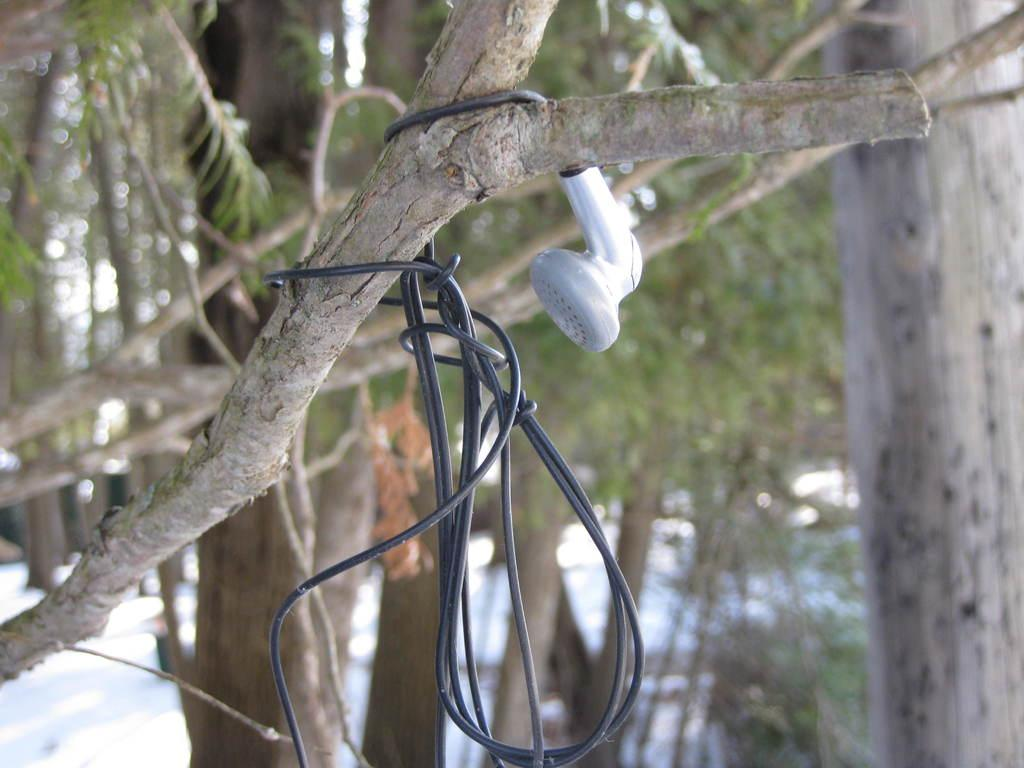What color is the wire that is visible in the image? The wire in the image is black. What is the wire connected to? The wire appears to be connected to a telephone. What can be seen in the background of the image? There are trees in the background of the image. Is there a parcel being delivered by a kite in the image? No, there is no parcel or kite present in the image. Is there a shop visible in the image? No, there is no shop visible in the image. 